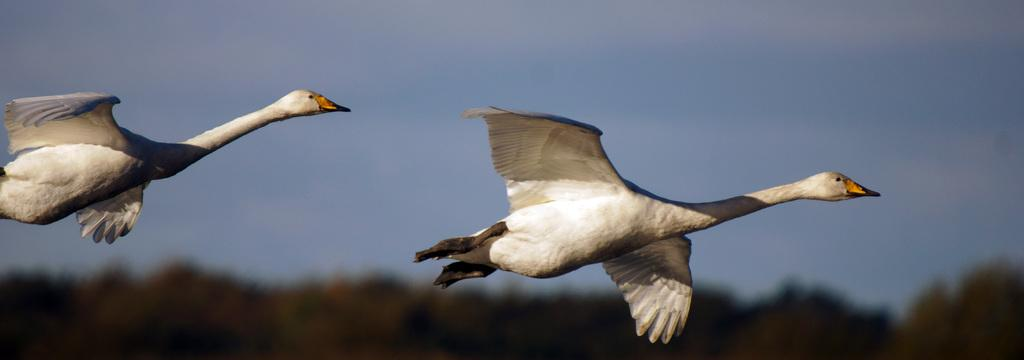How many birds can be seen in the image? There are 2 birds in the image. What color are the birds? The birds are off-white in color. Where are the birds located in the image? The birds are in the air. What can be seen in the background of the image? The background of the image includes the sky and trees. How is the image quality? The image is slightly blurred. What type of peace symbol can be seen in the image? There is no peace symbol present in the image; it features 2 off-white birds in the air. What season is depicted in the image? The image does not depict a specific season, as there are no seasonal indicators present. 